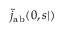<formula> <loc_0><loc_0><loc_500><loc_500>\tilde { j } _ { a b } ( \ r _ { 0 } , s | \ r )</formula> 